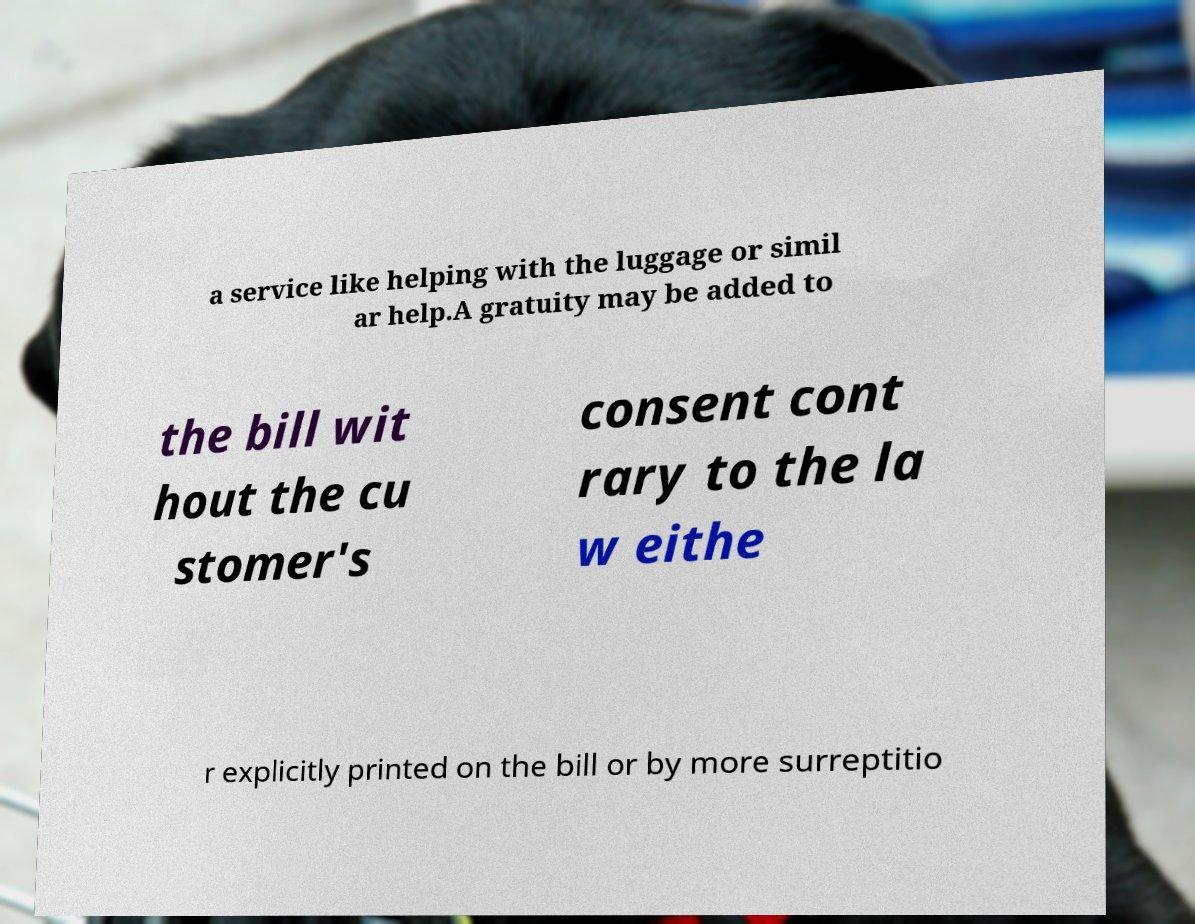For documentation purposes, I need the text within this image transcribed. Could you provide that? a service like helping with the luggage or simil ar help.A gratuity may be added to the bill wit hout the cu stomer's consent cont rary to the la w eithe r explicitly printed on the bill or by more surreptitio 